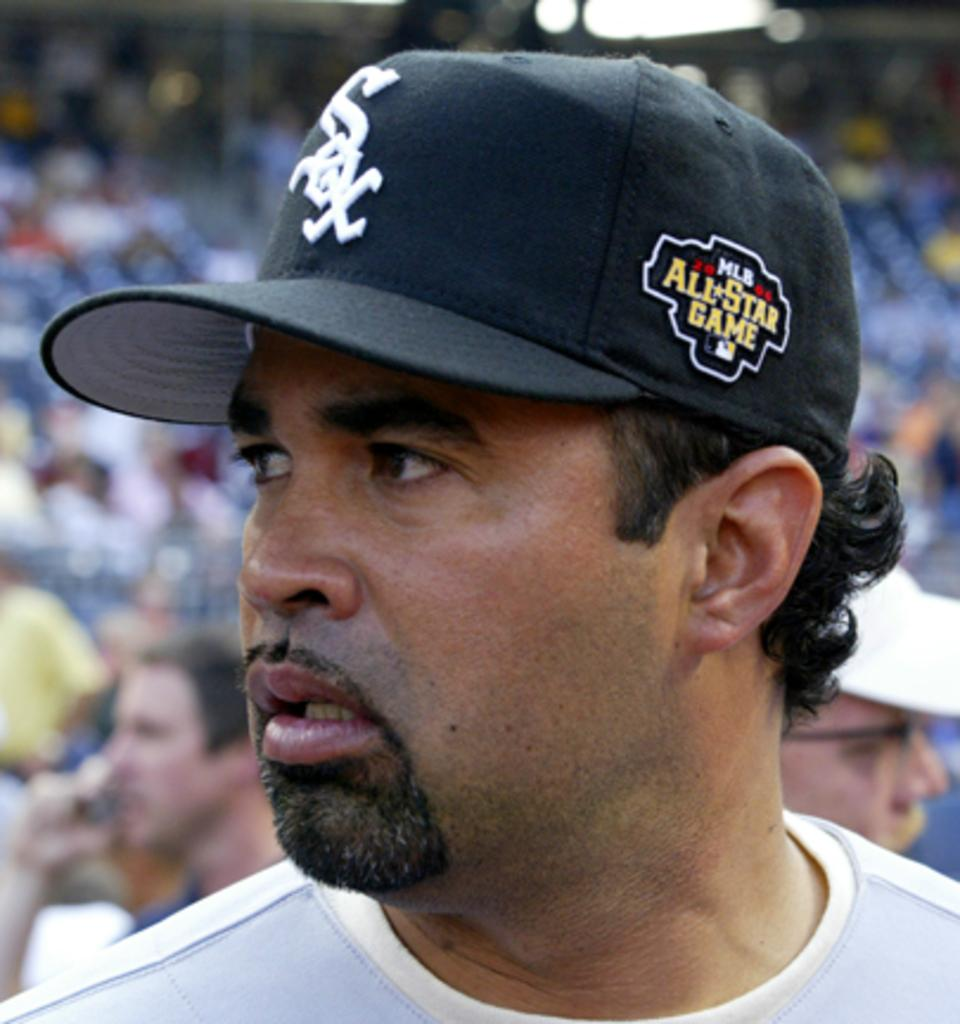<image>
Create a compact narrative representing the image presented. A baseball player is at a game wearing a Red Sox hat. 